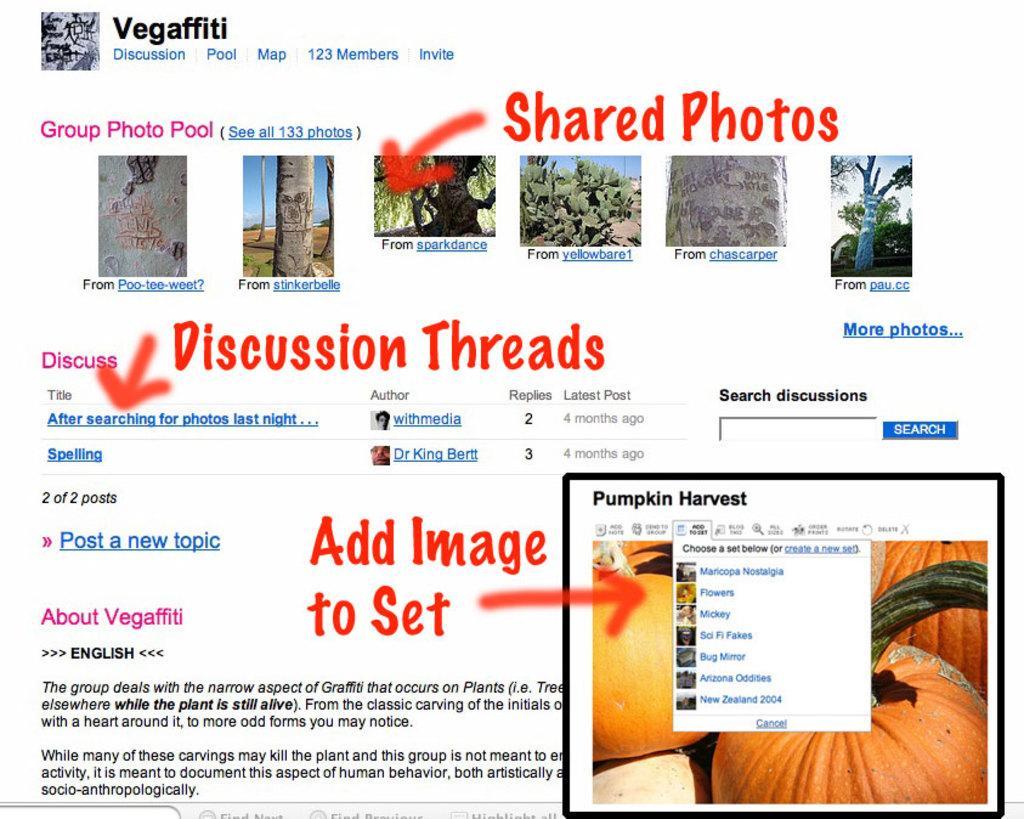Could you give a brief overview of what you see in this image? In the image it looks like it is a screenshot from some website. There are different pictures, texts, arrow marks and at the bottom right side there is another image. In that there are pumpkins and some other texts. 